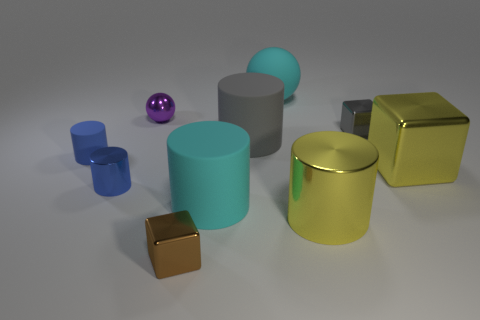How many other small things have the same shape as the brown metallic thing?
Make the answer very short. 1. Does the big cyan cylinder have the same material as the tiny cube left of the big shiny cylinder?
Provide a succinct answer. No. The yellow object that is the same material as the yellow cylinder is what size?
Provide a succinct answer. Large. There is a sphere that is on the right side of the cyan matte cylinder; how big is it?
Your answer should be very brief. Large. How many brown cubes are the same size as the gray rubber object?
Offer a very short reply. 0. What size is the other cylinder that is the same color as the small matte cylinder?
Your response must be concise. Small. Is there another thing of the same color as the tiny matte object?
Make the answer very short. Yes. The block that is the same size as the cyan cylinder is what color?
Keep it short and to the point. Yellow. There is a tiny matte object; is its color the same as the metal cylinder on the left side of the big metallic cylinder?
Your answer should be compact. Yes. The large cube has what color?
Your response must be concise. Yellow. 